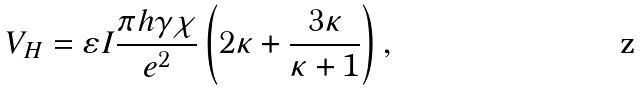<formula> <loc_0><loc_0><loc_500><loc_500>V _ { H } = \varepsilon I \frac { \pi h \gamma \chi } { e ^ { 2 } } \left ( 2 \kappa + \frac { 3 \kappa } { \kappa + 1 } \right ) ,</formula> 